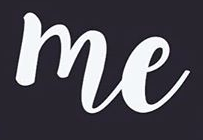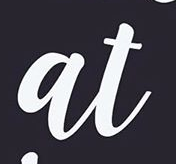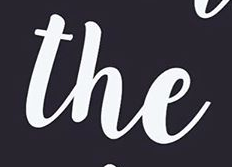Transcribe the words shown in these images in order, separated by a semicolon. me; at; the 